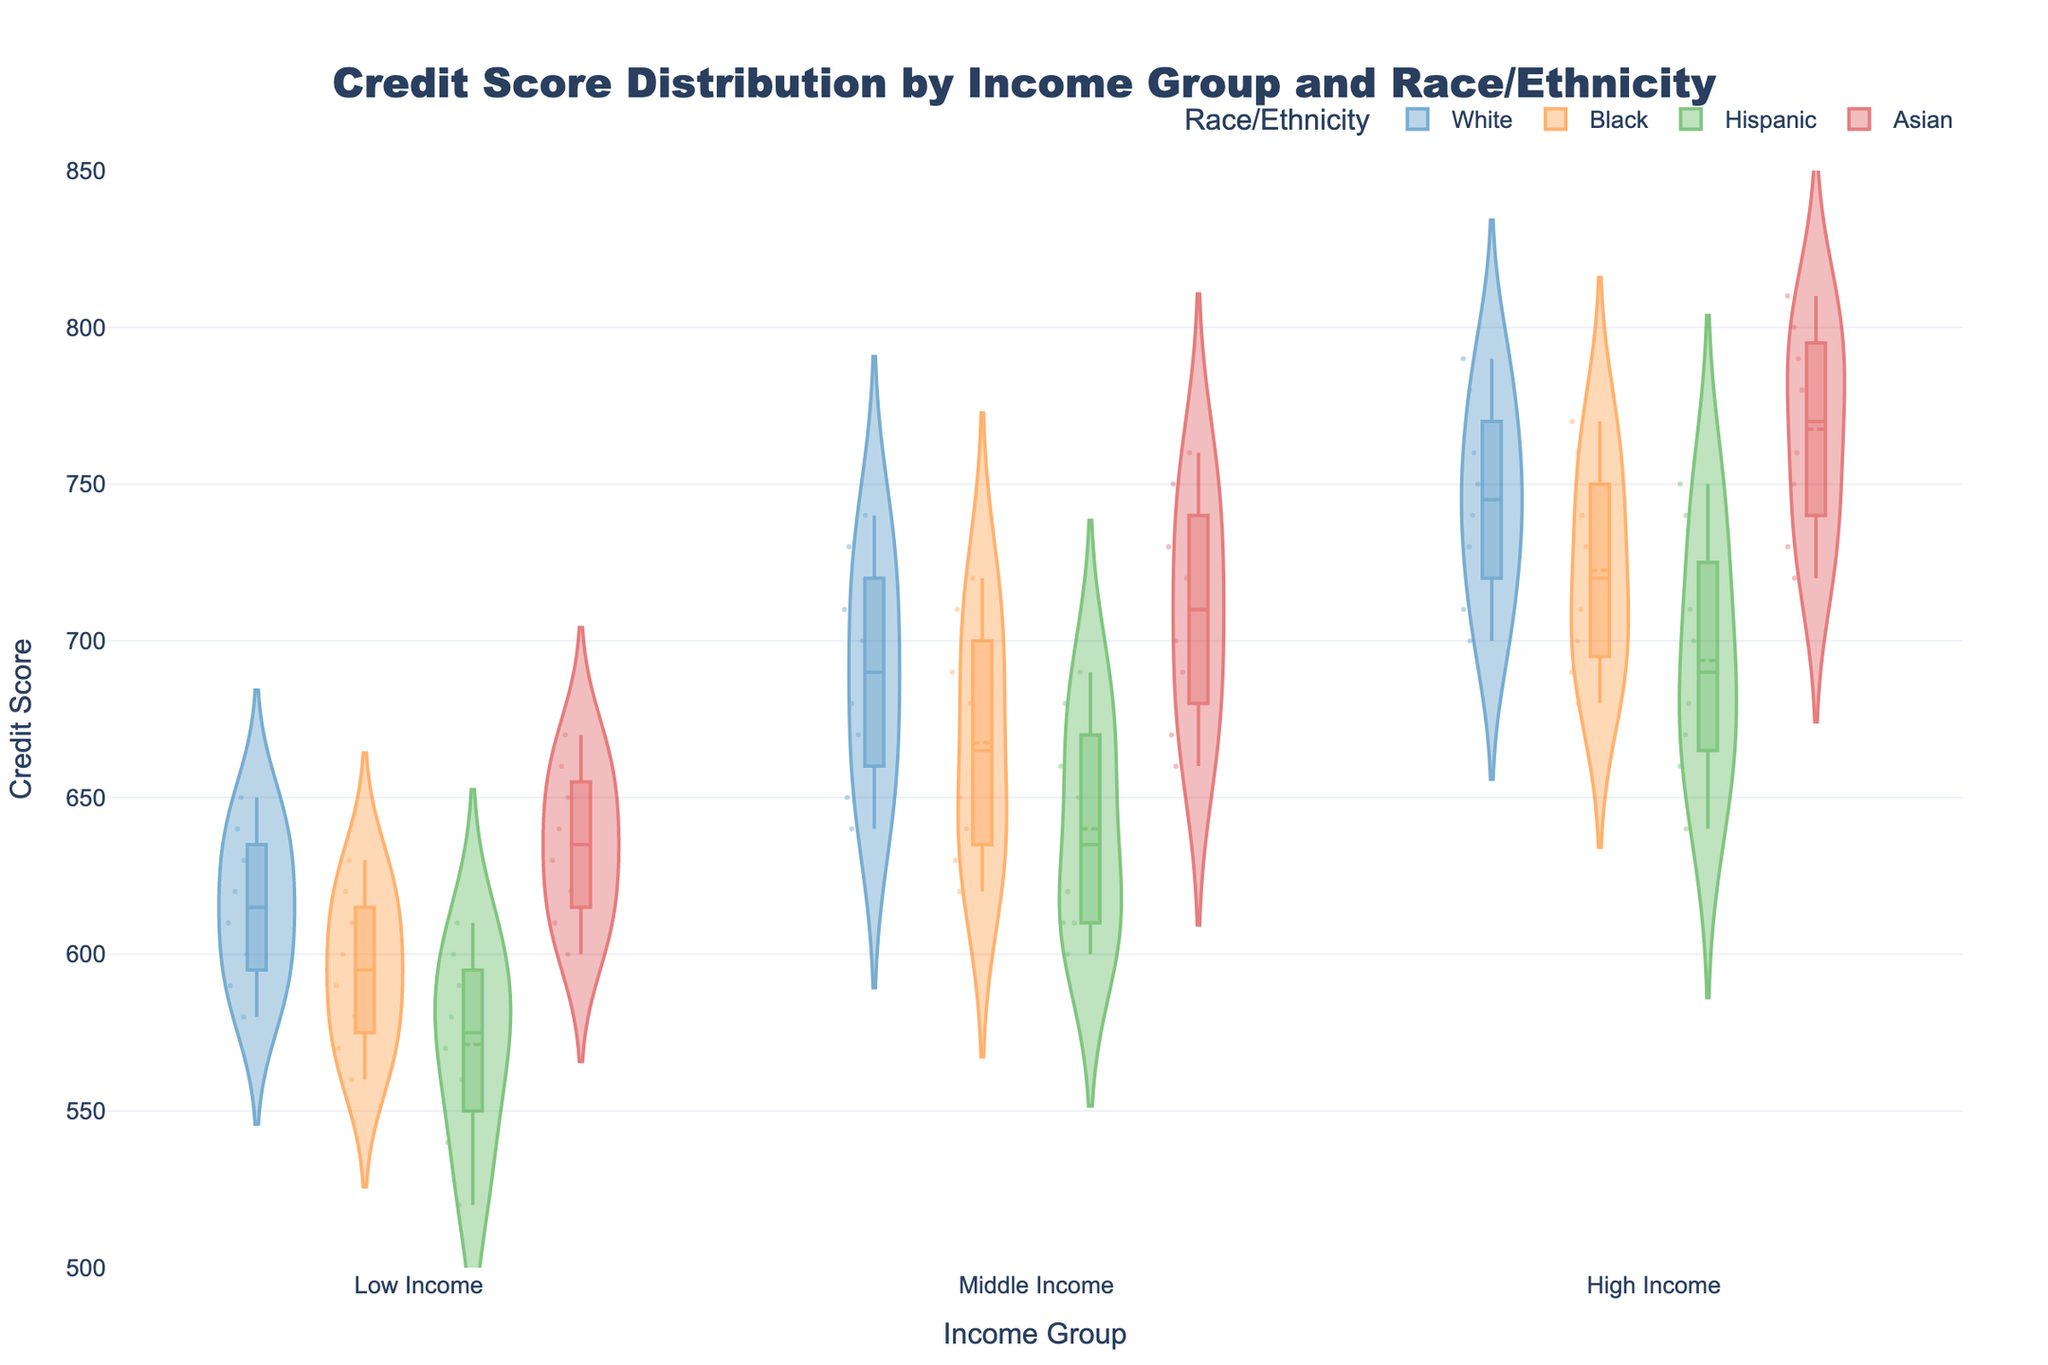What is the title of the figure? The title is displayed at the top of the figure and provides the main subject of the visual. It reads, "Credit Score Distribution by Income Group and Race/Ethnicity."
Answer: Credit Score Distribution by Income Group and Race/Ethnicity Which axis represents the credit score? The axes are labeled prominently, with the y-axis being specified for credit scores. The y-axis label is "Credit Score."
Answer: y-axis How are the income groups ordered on the x-axis? The x-axis is organized into three categories, visible from left to right: "Low Income," "Middle Income," and "High Income."
Answer: Low Income, Middle Income, High Income Which race/ethnicity group has the highest median credit score in the 55+ age group for high income? Observing the median lines within the violin plots under the "High Income" category for the 55+ age group, the highest median credit score belongs to the "Asian" group.
Answer: Asian Among all age groups and income levels, which race/ethnicity group shows the widest distribution of credit scores? By examining the spread and length of the violin plots for each race/ethnicity group, the widest distribution appears to be in the "Asian" group's high-income category.
Answer: Asian How does the median credit score for low-income Hispanic individuals compare between the 25-34 and 35-44 age groups? By comparing the median line inside the violin plots for "Low Income" under both age groups for "Hispanic" individuals, the 35-44 age group shows a higher median score than the 25-34 age group.
Answer: Higher What is the credit score range for middle-income Black individuals in the 45-54 age group? The range of the violin plot representing "Middle Income" for "Black" individuals in the 45-54 age group extends from the lowest visible point to the highest, approximately from 680 to 690.
Answer: 680 to 690 Do high-income White individuals generally have higher or lower credit scores compared to high-income Black individuals across all age groups? By comparing the median lines and the overall vertical positions of the violin plots of high-income "White" and "Black" individuals across all age groups, "White" individuals generally have higher credit scores.
Answer: Higher Which income group shows the smallest variation in credit scores among Asian individuals aged 35-44? The tightness and smaller spread of the violin plot for "Asian" individuals aged 35-44 indicate that the "Middle Income" group shows the smallest variation.
Answer: Middle Income What is the average median credit score of high-income individuals across all race/ethnicity groups in the 55+ age group? The median credit scores for high-income "White," "Black," "Hispanic," and "Asian" groups are observed. They are approximately 785, 765, 745, and 805 respectively. The average is calculated as (785 + 765 + 745 + 805) / 4.
Answer: 775 